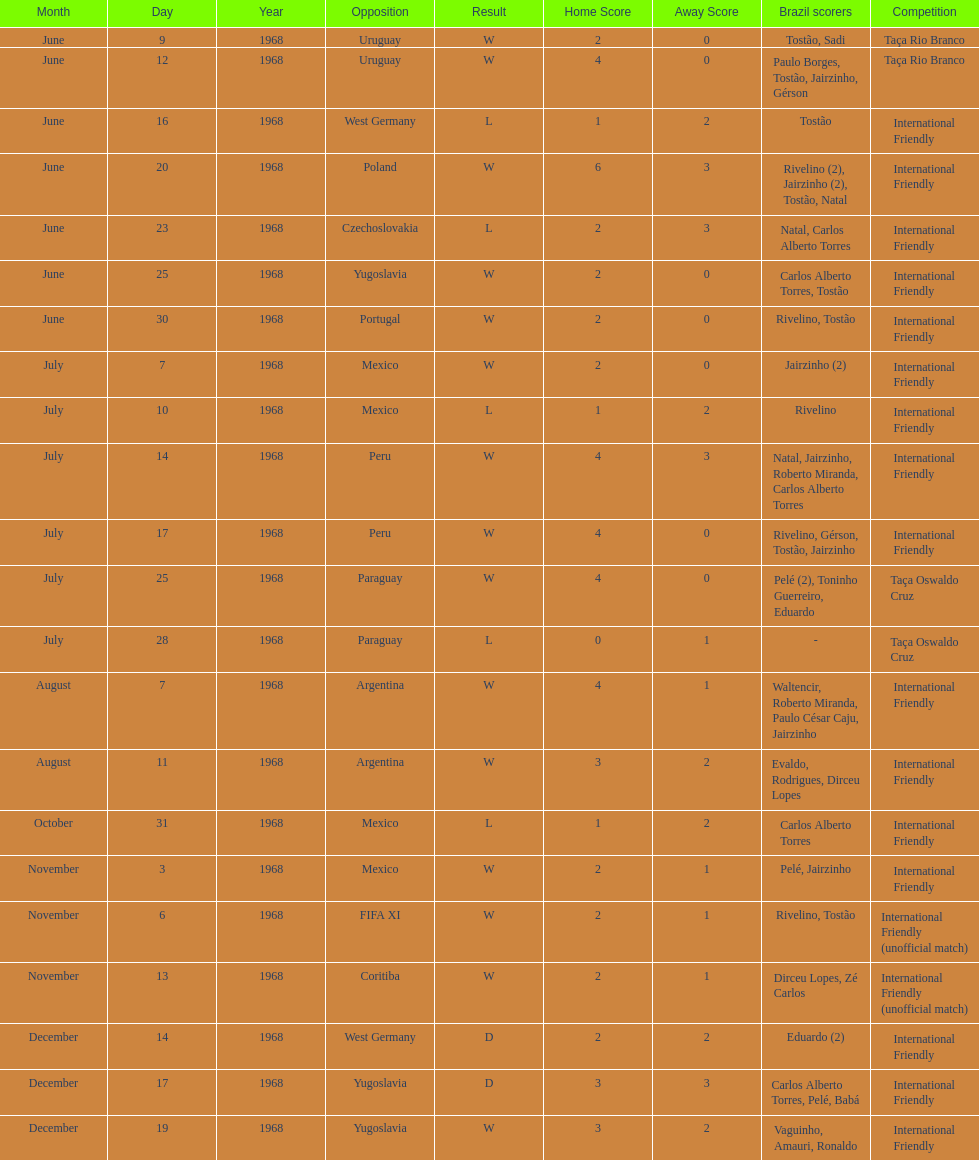The most goals scored by brazil in a game 6. 